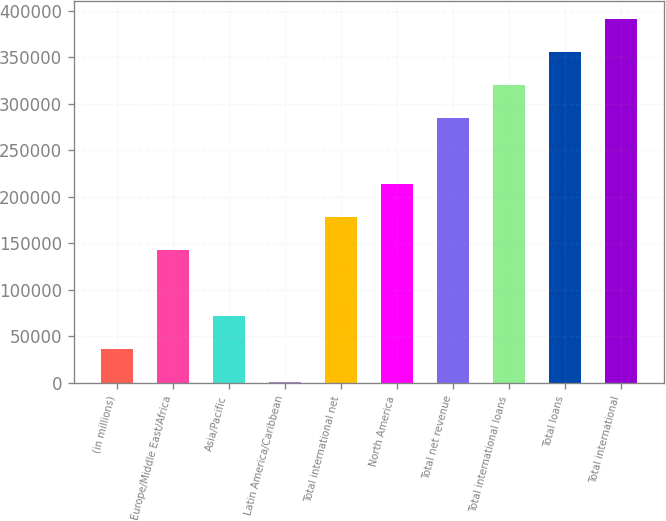Convert chart. <chart><loc_0><loc_0><loc_500><loc_500><bar_chart><fcel>(in millions)<fcel>Europe/Middle East/Africa<fcel>Asia/Pacific<fcel>Latin America/Caribbean<fcel>Total international net<fcel>North America<fcel>Total net revenue<fcel>Total international loans<fcel>Total loans<fcel>Total international<nl><fcel>36956.3<fcel>143226<fcel>72379.6<fcel>1533<fcel>178650<fcel>214073<fcel>284919<fcel>320343<fcel>355766<fcel>391189<nl></chart> 